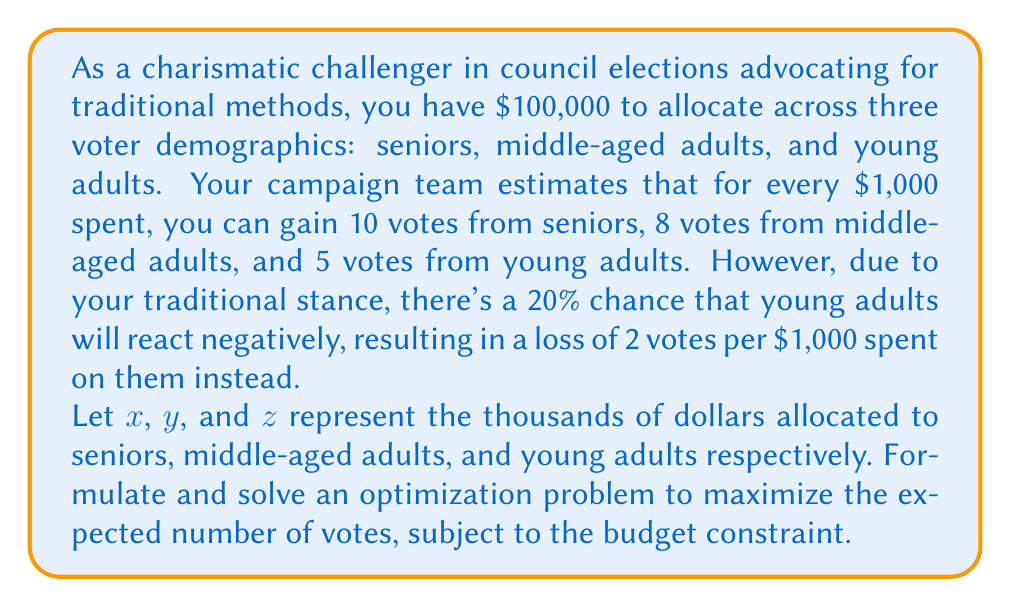Can you solve this math problem? To solve this problem, we need to set up an expected value function and maximize it subject to the budget constraint. Let's break it down step-by-step:

1) First, let's define our objective function. The expected number of votes gained:

   $E(V) = 10x + 8y + (0.8 \cdot 5z + 0.2 \cdot (-2z))$
   
   Simplifying: $E(V) = 10x + 8y + 3.6z$

2) Our constraint is the budget:

   $x + y + z = 100$ (since we're working in thousands)

3) We want to maximize $E(V)$ subject to this constraint. This is a linear programming problem, which can be solved using the simplex method. However, given the nature of the problem, we can also solve it using the concept of marginal returns.

4) The marginal return for each group is:
   - Seniors: 10 votes per $1,000
   - Middle-aged: 8 votes per $1,000
   - Young adults: 3.6 votes per $1,000 (expected)

5) To maximize votes, we should allocate resources to the group with the highest marginal return first, then the second highest, and so on until the budget is exhausted.

6) Therefore, the optimal allocation is:
   - Allocate all $100,000 to seniors

This solution assumes that there are no diminishing returns or other constraints on how much can be spent on each demographic.
Answer: The optimal distribution of campaign resources is:
$$
\begin{aligned}
x &= 100 \text{ (Seniors: \$100,000)} \\
y &= 0 \text{ (Middle-aged: \$0)} \\
z &= 0 \text{ (Young adults: \$0)}
\end{aligned}
$$
This allocation is expected to yield 1,000 votes. 